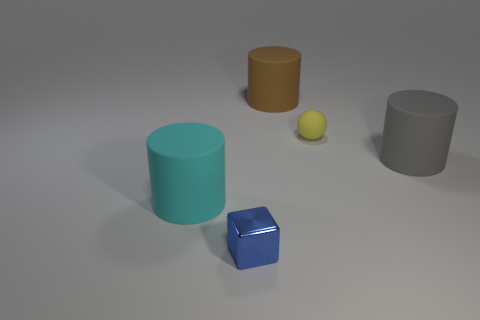Is there any other thing that has the same material as the small blue object?
Ensure brevity in your answer.  No. Do the rubber object in front of the gray thing and the yellow matte thing in front of the large brown cylinder have the same size?
Make the answer very short. No. What number of objects are either big gray matte cylinders or balls in front of the brown thing?
Your answer should be very brief. 2. Is there another big rubber object of the same shape as the big cyan thing?
Provide a succinct answer. Yes. There is a yellow ball that is in front of the rubber object behind the small sphere; what size is it?
Make the answer very short. Small. How many metal things are yellow spheres or cylinders?
Your answer should be compact. 0. What number of purple balls are there?
Your response must be concise. 0. Does the small thing behind the cyan matte cylinder have the same material as the large object in front of the large gray rubber cylinder?
Your response must be concise. Yes. The tiny thing behind the big object that is on the left side of the brown matte thing is made of what material?
Offer a terse response. Rubber. There is a object that is left of the blue object; is it the same shape as the matte object that is on the right side of the tiny yellow matte sphere?
Give a very brief answer. Yes. 